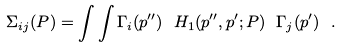Convert formula to latex. <formula><loc_0><loc_0><loc_500><loc_500>\Sigma _ { i j } ( P ) = \int \int \Gamma _ { i } ( { p } ^ { \prime \prime } ) \ H _ { 1 } ( { p } ^ { \prime \prime } , { p } ^ { \prime } ; P ) \ \Gamma _ { j } ( { p } ^ { \prime } ) \ .</formula> 